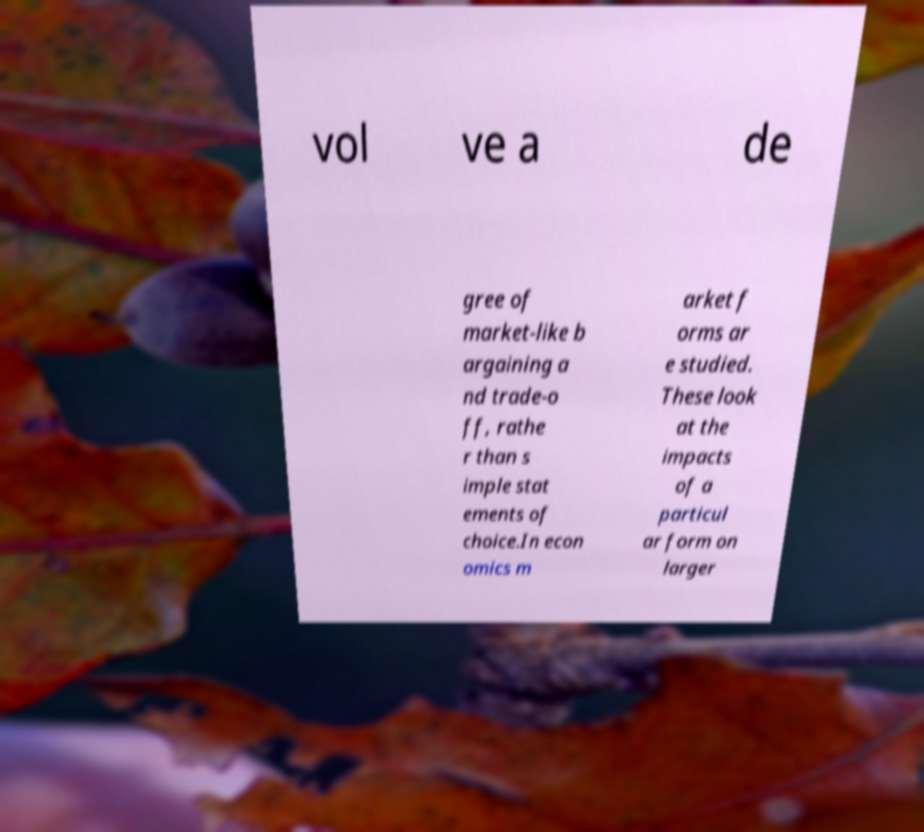Could you extract and type out the text from this image? vol ve a de gree of market-like b argaining a nd trade-o ff, rathe r than s imple stat ements of choice.In econ omics m arket f orms ar e studied. These look at the impacts of a particul ar form on larger 